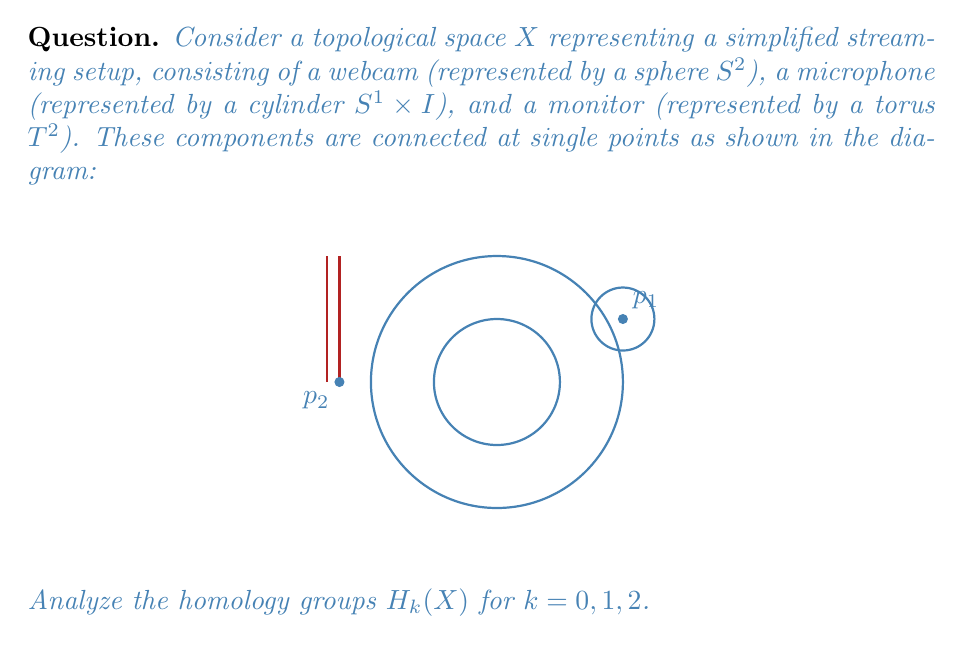Can you answer this question? To analyze the homology groups of this topological space, we'll use the Mayer-Vietoris sequence and the known homology groups of the individual components.

Step 1: Identify the subspaces
Let $A$ be the union of the sphere (webcam) and the cylinder (microphone), and $B$ be the torus (monitor).
$A \cap B$ consists of two points, $p_1$ and $p_2$.

Step 2: Known homology groups
- Sphere $S^2$: $H_0(S^2) \cong \mathbb{Z}$, $H_2(S^2) \cong \mathbb{Z}$, others are 0
- Cylinder $S^1 \times I$: $H_0(S^1 \times I) \cong \mathbb{Z}$, $H_1(S^1 \times I) \cong \mathbb{Z}$, others are 0
- Torus $T^2$: $H_0(T^2) \cong \mathbb{Z}$, $H_1(T^2) \cong \mathbb{Z} \oplus \mathbb{Z}$, $H_2(T^2) \cong \mathbb{Z}$, others are 0

Step 3: Analyze $H_0(X)$
The space $X$ is path-connected, so $H_0(X) \cong \mathbb{Z}$.

Step 4: Analyze $H_1(X)$
Use the Mayer-Vietoris sequence:
$$\cdots \to H_1(A \cap B) \to H_1(A) \oplus H_1(B) \to H_1(X) \to H_0(A \cap B) \to H_0(A) \oplus H_0(B) \to \cdots$$

$H_1(A \cap B) = 0$ (two points)
$H_1(A) \oplus H_1(B) \cong \mathbb{Z} \oplus (\mathbb{Z} \oplus \mathbb{Z}) \cong \mathbb{Z}^3$
$H_0(A \cap B) \cong \mathbb{Z}^2$ (two points)
$H_0(A) \oplus H_0(B) \cong \mathbb{Z} \oplus \mathbb{Z} \cong \mathbb{Z}^2$

The sequence becomes:
$$0 \to \mathbb{Z}^3 \to H_1(X) \to \mathbb{Z}^2 \to \mathbb{Z}^2$$

The last map is surjective, so $H_1(X) \cong \mathbb{Z}^3$.

Step 5: Analyze $H_2(X)$
Continue the Mayer-Vietoris sequence:
$$\cdots \to H_2(A \cap B) \to H_2(A) \oplus H_2(B) \to H_2(X) \to H_1(A \cap B) \to \cdots$$

$H_2(A \cap B) = 0$
$H_2(A) \oplus H_2(B) \cong \mathbb{Z} \oplus \mathbb{Z} \cong \mathbb{Z}^2$
$H_1(A \cap B) = 0$

The sequence becomes:
$$0 \to \mathbb{Z}^2 \to H_2(X) \to 0$$

Therefore, $H_2(X) \cong \mathbb{Z}^2$.

Step 6: Higher homology groups
All higher homology groups ($k > 2$) are trivial because the individual components have trivial homology groups in these dimensions.
Answer: $H_0(X) \cong \mathbb{Z}$, $H_1(X) \cong \mathbb{Z}^3$, $H_2(X) \cong \mathbb{Z}^2$, $H_k(X) = 0$ for $k > 2$ 